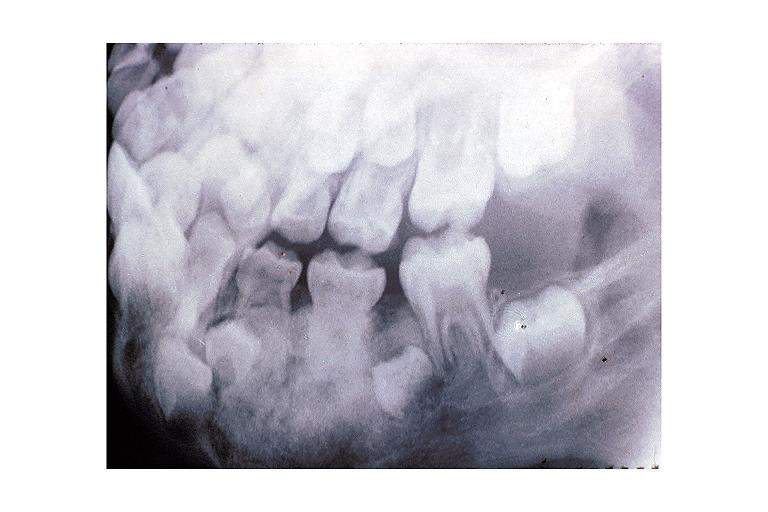what does this image show?
Answer the question using a single word or phrase. Osteoblastoma 